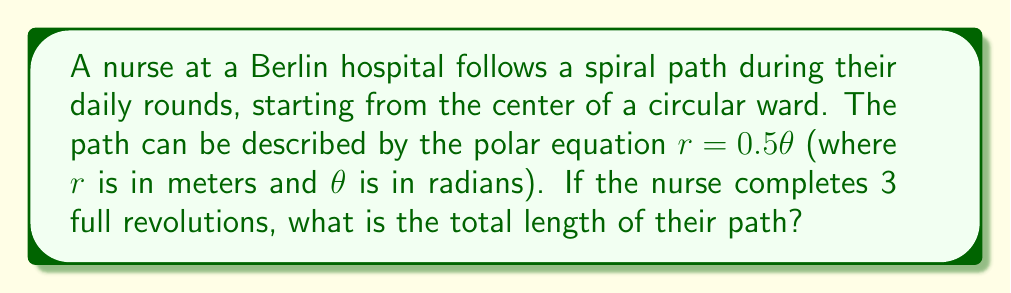What is the answer to this math problem? To solve this problem, we need to use the formula for the arc length of a curve in polar coordinates and integrate it over the given interval. The steps are as follows:

1) The formula for the arc length $L$ of a curve in polar coordinates is:

   $$L = \int_a^b \sqrt{r^2 + \left(\frac{dr}{d\theta}\right)^2} d\theta$$

2) We're given that $r = 0.5\theta$. We need to find $\frac{dr}{d\theta}$:

   $$\frac{dr}{d\theta} = 0.5$$

3) Substituting these into the arc length formula:

   $$L = \int_a^b \sqrt{(0.5\theta)^2 + (0.5)^2} d\theta$$

4) Simplifying under the square root:

   $$L = \int_a^b \sqrt{0.25\theta^2 + 0.25} d\theta = 0.5\int_a^b \sqrt{\theta^2 + 1} d\theta$$

5) The nurse completes 3 full revolutions, so $\theta$ goes from 0 to $6\pi$ radians:

   $$L = 0.5\int_0^{6\pi} \sqrt{\theta^2 + 1} d\theta$$

6) This integral doesn't have an elementary antiderivative. We can solve it using the substitution $\theta = \sinh u$:

   $$L = 0.5\int_0^{\sinh^{-1}(6\pi)} \sqrt{\sinh^2 u + 1} \cosh u du$$

7) Simplify using the identity $\sinh^2 u + 1 = \cosh^2 u$:

   $$L = 0.5\int_0^{\sinh^{-1}(6\pi)} \cosh^2 u du$$

8) The antiderivative of $\cosh^2 u$ is $\frac{1}{4}(2u + \sinh(2u))$, so:

   $$L = 0.5 \cdot \frac{1}{4}[2u + \sinh(2u)]_0^{\sinh^{-1}(6\pi)}$$

9) Evaluating this and simplifying:

   $$L = \frac{1}{4}[\sinh^{-1}(6\pi) + 6\pi\sqrt{1+(6\pi)^2}]$$

10) This can be evaluated numerically to get the final answer.
Answer: The total length of the nurse's path is approximately 57.62 meters. 